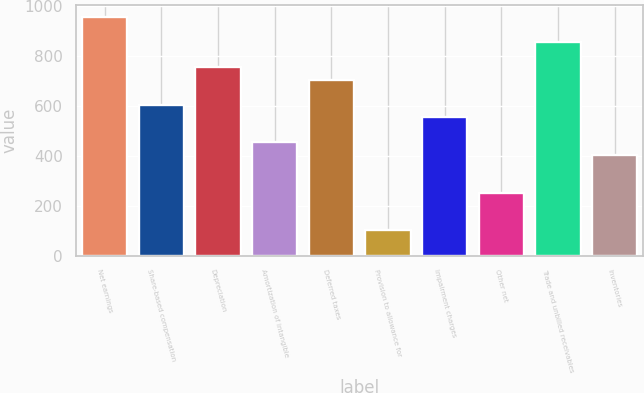Convert chart to OTSL. <chart><loc_0><loc_0><loc_500><loc_500><bar_chart><fcel>Net earnings<fcel>Share-based compensation<fcel>Depreciation<fcel>Amortization of intangible<fcel>Deferred taxes<fcel>Provision to allowance for<fcel>Impairment charges<fcel>Other net<fcel>Trade and unbilled receivables<fcel>Inventories<nl><fcel>955.55<fcel>603.8<fcel>754.55<fcel>453.05<fcel>704.3<fcel>101.3<fcel>553.55<fcel>252.05<fcel>855.05<fcel>402.8<nl></chart> 